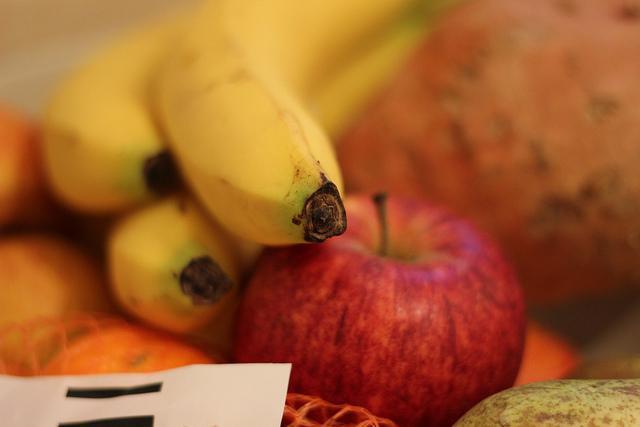Is the given caption "The banana is touching the apple." fitting for the image?
Answer yes or no. Yes. Verify the accuracy of this image caption: "The apple is left of the banana.".
Answer yes or no. No. 